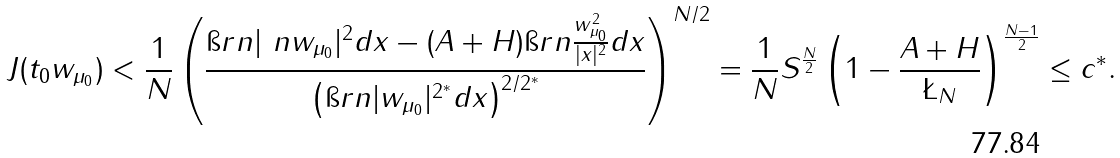<formula> <loc_0><loc_0><loc_500><loc_500>J ( t _ { 0 } w _ { \mu _ { 0 } } ) < \frac { 1 } { N } \left ( \frac { \i r n | \ n w _ { \mu _ { 0 } } | ^ { 2 } d x - ( A + H ) \i r n \frac { w _ { \mu _ { 0 } } ^ { 2 } } { | x | ^ { 2 } } d x } { \left ( \i r n | w _ { \mu _ { 0 } } | ^ { 2 ^ { * } } d x \right ) ^ { 2 / 2 ^ { * } } } \right ) ^ { N / 2 } = \frac { 1 } { N } S ^ { \frac { N } { 2 } } \left ( 1 - \frac { A + H } { \L _ { N } } \right ) ^ { \frac { N - 1 } { 2 } } \leq c ^ { * } .</formula> 